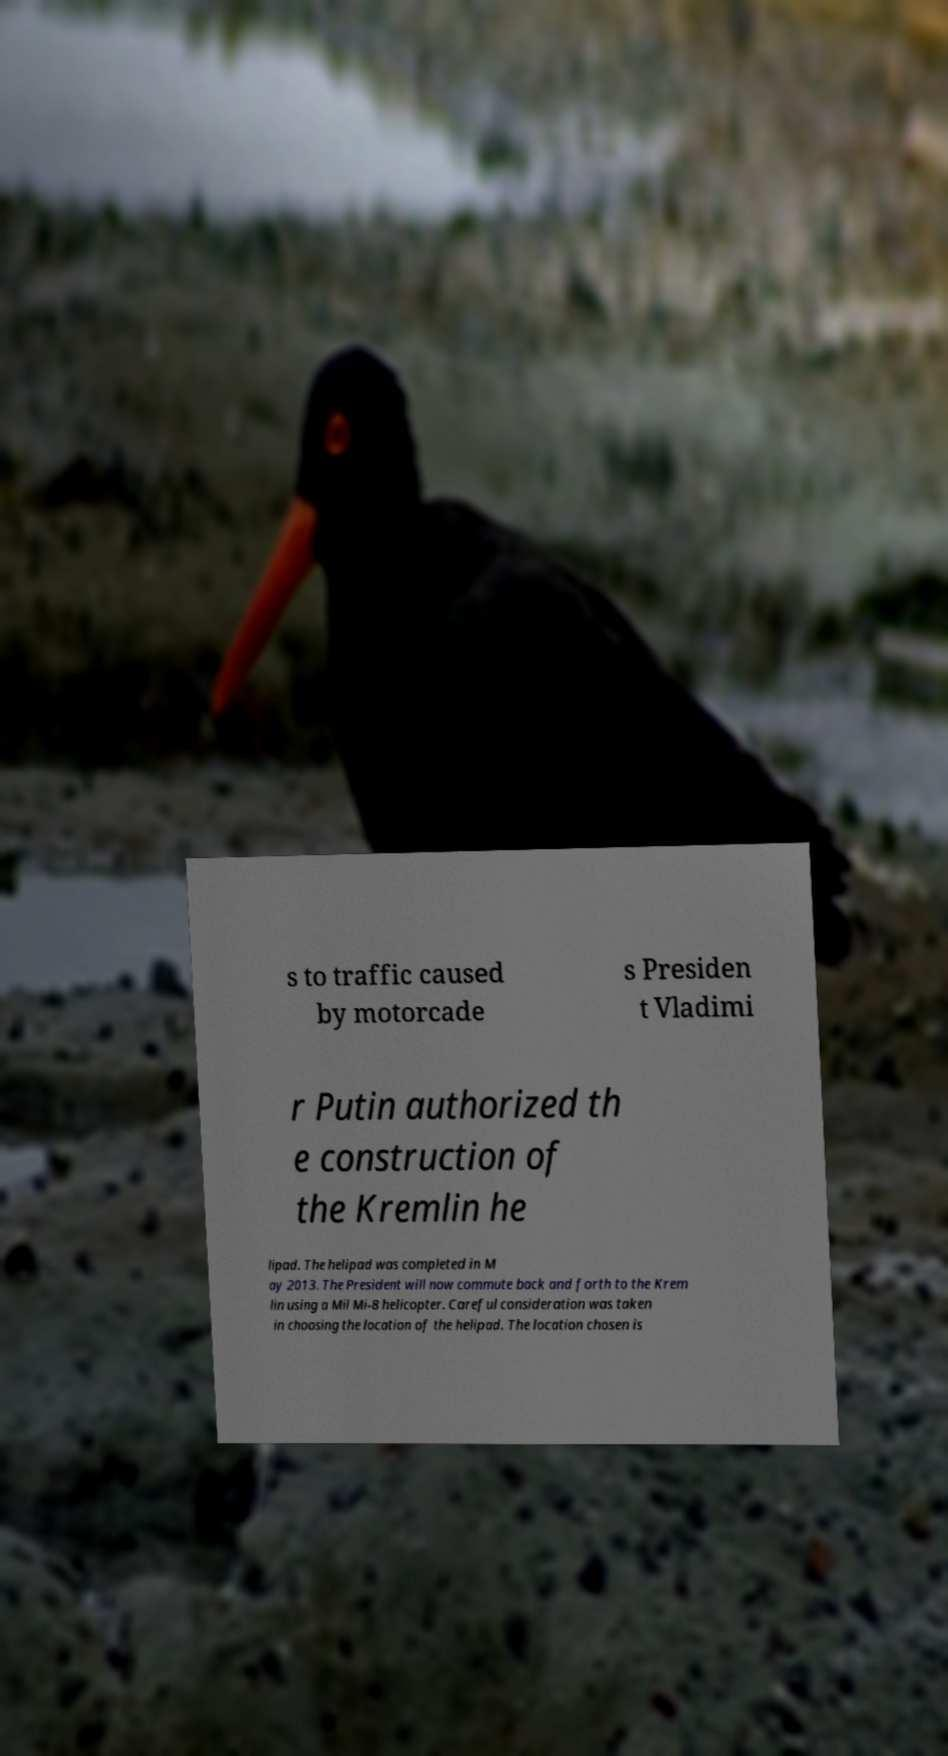What messages or text are displayed in this image? I need them in a readable, typed format. s to traffic caused by motorcade s Presiden t Vladimi r Putin authorized th e construction of the Kremlin he lipad. The helipad was completed in M ay 2013. The President will now commute back and forth to the Krem lin using a Mil Mi-8 helicopter. Careful consideration was taken in choosing the location of the helipad. The location chosen is 